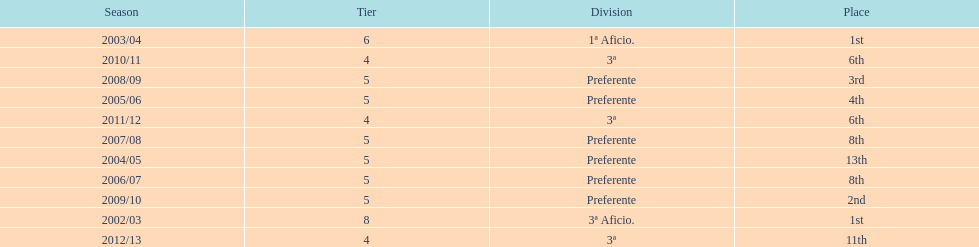What place was 1a aficio and 3a aficio? 1st. 